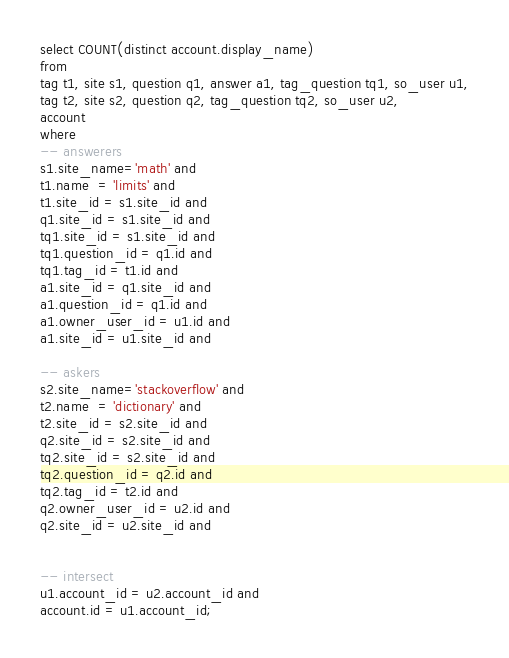<code> <loc_0><loc_0><loc_500><loc_500><_SQL_>
select COUNT(distinct account.display_name)
from
tag t1, site s1, question q1, answer a1, tag_question tq1, so_user u1,
tag t2, site s2, question q2, tag_question tq2, so_user u2,
account
where
-- answerers
s1.site_name='math' and
t1.name  = 'limits' and
t1.site_id = s1.site_id and
q1.site_id = s1.site_id and
tq1.site_id = s1.site_id and
tq1.question_id = q1.id and
tq1.tag_id = t1.id and
a1.site_id = q1.site_id and
a1.question_id = q1.id and
a1.owner_user_id = u1.id and
a1.site_id = u1.site_id and

-- askers
s2.site_name='stackoverflow' and
t2.name  = 'dictionary' and
t2.site_id = s2.site_id and
q2.site_id = s2.site_id and
tq2.site_id = s2.site_id and
tq2.question_id = q2.id and
tq2.tag_id = t2.id and
q2.owner_user_id = u2.id and
q2.site_id = u2.site_id and


-- intersect
u1.account_id = u2.account_id and
account.id = u1.account_id;

</code> 